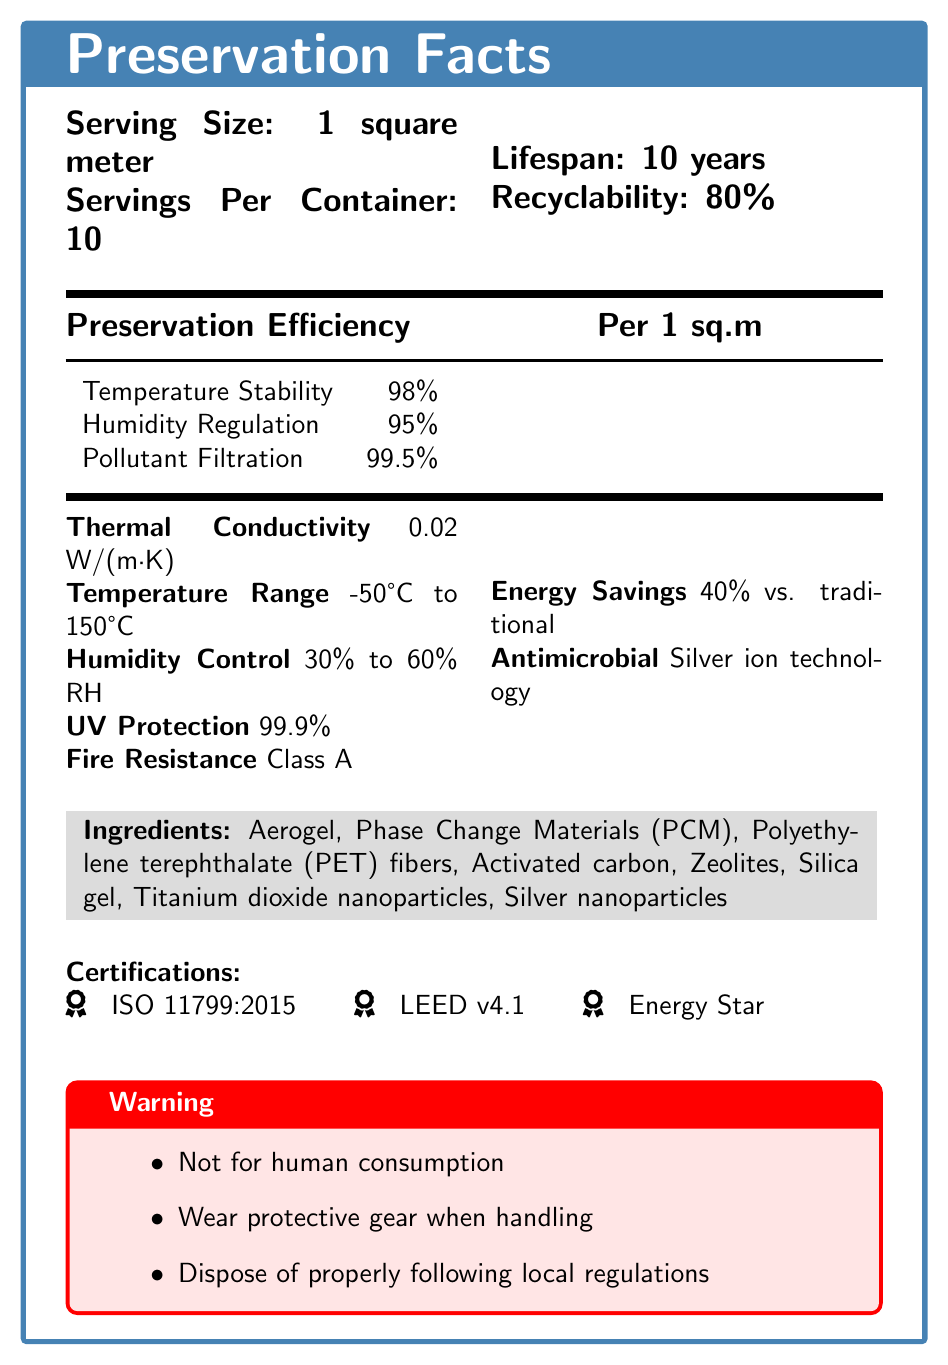what is the serving size? The document states that the serving size is 1 square meter.
Answer: 1 square meter how many servings are there per container? The document specifies there are 10 servings per container.
Answer: 10 what is the thermal conductivity of the material? The document lists the thermal conductivity as 0.02 W/(m·K).
Answer: 0.02 W/(m·K) what is the temperature range for this material? The document states that the temperature range is -50°C to 150°C.
Answer: -50°C to 150°C what certifications does this material have? The document lists the certifications as ISO 11799:2015, LEED v4.1, and Energy Star.
Answer: ISO 11799:2015, LEED v4.1, Energy Star which of the following is an ingredient in the material? A. Carbon nanotubes B. Aerogel C. Graphene D. Kevlar The document lists Aerogel as an ingredient, but does not mention Carbon nanotubes, Graphene, or Kevlar.
Answer: B what is the fire resistance class of this material? A. Class A B. Class B C. Class C D. Class D The document states that the fire resistance class is Class A.
Answer: A does this material have UV protection? The document states that the material provides 99.9% UV protection.
Answer: Yes describe the main idea of the document. The main idea of the document is to give comprehensive nutritional and preservation information on advanced materials designed for artifact preservation, including technical specifications and safety guidelines.
Answer: The document provides detailed nutritional and preservation facts for advanced temperature-regulating materials used in artifact preservation. It includes information about serving size, thermal conductivity, temperature range, humidity control, UV protection, fire resistance, antimicrobial properties, ingredients, certifications, and warnings. what is the percentage of pollutant filtration provided by the material? The document lists the pollutant filtration efficiency as 99.5%.
Answer: 99.5% what warnings are provided in the document? The document includes warnings against human consumption, to wear protective gear when handling, and to dispose of the material properly following local regulations.
Answer: Not for human consumption, Wear protective gear when handling, Dispose of properly following local regulations what is the lifespan of this material? The document states that the lifespan of the material is 10 years.
Answer: 10 years what energy savings does this material offer compared to traditional systems? The document specifies that the material offers 40% energy savings compared to traditional systems.
Answer: 40% does this material contain any phase change materials? The document lists Phase Change Materials (PCM) as one of the ingredients.
Answer: Yes what is the humidity control range of this material? The document states that the humidity control range is 30% to 60% relative humidity.
Answer: 30% to 60% RH what is the antimicrobial technology used in this material? The document specifies that the antimicrobial properties are due to Silver ion technology.
Answer: Silver ion technology can the recyclability of this material be determined from the document? The document states that the recyclability of the material is 80%.
Answer: Yes who is the manufacturer of the material? The document does not provide any information about the manufacturer.
Answer: Not enough information 